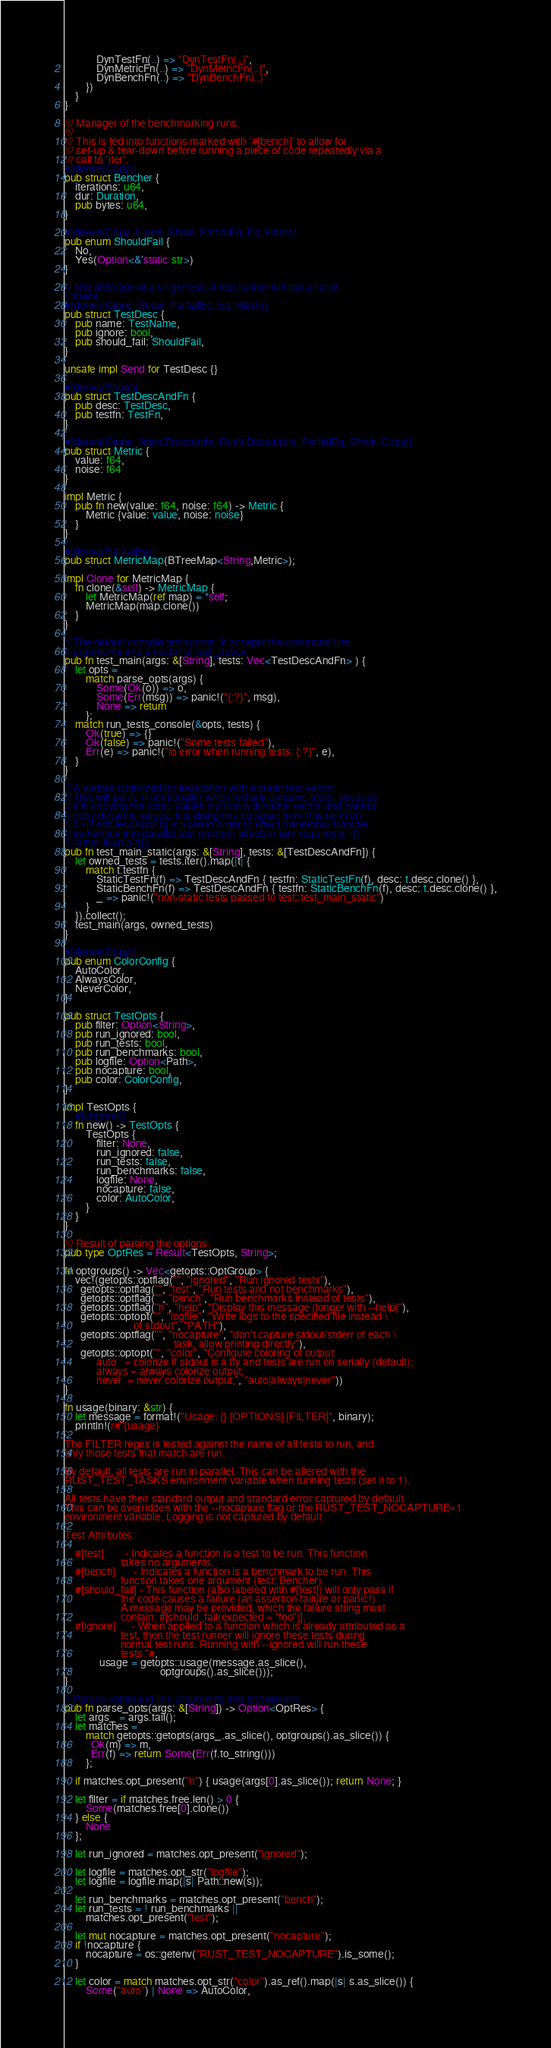Convert code to text. <code><loc_0><loc_0><loc_500><loc_500><_Rust_>            DynTestFn(..) => "DynTestFn(..)",
            DynMetricFn(..) => "DynMetricFn(..)",
            DynBenchFn(..) => "DynBenchFn(..)"
        })
    }
}

/// Manager of the benchmarking runs.
///
/// This is fed into functions marked with `#[bench]` to allow for
/// set-up & tear-down before running a piece of code repeatedly via a
/// call to `iter`.
#[derive(Copy)]
pub struct Bencher {
    iterations: u64,
    dur: Duration,
    pub bytes: u64,
}

#[derive(Copy, Clone, Show, PartialEq, Eq, Hash)]
pub enum ShouldFail {
    No,
    Yes(Option<&'static str>)
}

// The definition of a single test. A test runner will run a list of
// these.
#[derive(Clone, Show, PartialEq, Eq, Hash)]
pub struct TestDesc {
    pub name: TestName,
    pub ignore: bool,
    pub should_fail: ShouldFail,
}

unsafe impl Send for TestDesc {}

#[derive(Show)]
pub struct TestDescAndFn {
    pub desc: TestDesc,
    pub testfn: TestFn,
}

#[derive(Clone, RustcEncodable, RustcDecodable, PartialEq, Show, Copy)]
pub struct Metric {
    value: f64,
    noise: f64
}

impl Metric {
    pub fn new(value: f64, noise: f64) -> Metric {
        Metric {value: value, noise: noise}
    }
}

#[derive(PartialEq)]
pub struct MetricMap(BTreeMap<String,Metric>);

impl Clone for MetricMap {
    fn clone(&self) -> MetricMap {
        let MetricMap(ref map) = *self;
        MetricMap(map.clone())
    }
}

// The default console test runner. It accepts the command line
// arguments and a vector of test_descs.
pub fn test_main(args: &[String], tests: Vec<TestDescAndFn> ) {
    let opts =
        match parse_opts(args) {
            Some(Ok(o)) => o,
            Some(Err(msg)) => panic!("{:?}", msg),
            None => return
        };
    match run_tests_console(&opts, tests) {
        Ok(true) => {}
        Ok(false) => panic!("Some tests failed"),
        Err(e) => panic!("io error when running tests: {:?}", e),
    }
}

// A variant optimized for invocation with a static test vector.
// This will panic (intentionally) when fed any dynamic tests, because
// it is copying the static values out into a dynamic vector and cannot
// copy dynamic values. It is doing this because from this point on
// a ~[TestDescAndFn] is used in order to effect ownership-transfer
// semantics into parallel test runners, which in turn requires a ~[]
// rather than a &[].
pub fn test_main_static(args: &[String], tests: &[TestDescAndFn]) {
    let owned_tests = tests.iter().map(|t| {
        match t.testfn {
            StaticTestFn(f) => TestDescAndFn { testfn: StaticTestFn(f), desc: t.desc.clone() },
            StaticBenchFn(f) => TestDescAndFn { testfn: StaticBenchFn(f), desc: t.desc.clone() },
            _ => panic!("non-static tests passed to test::test_main_static")
        }
    }).collect();
    test_main(args, owned_tests)
}

#[derive(Copy)]
pub enum ColorConfig {
    AutoColor,
    AlwaysColor,
    NeverColor,
}

pub struct TestOpts {
    pub filter: Option<String>,
    pub run_ignored: bool,
    pub run_tests: bool,
    pub run_benchmarks: bool,
    pub logfile: Option<Path>,
    pub nocapture: bool,
    pub color: ColorConfig,
}

impl TestOpts {
    #[cfg(test)]
    fn new() -> TestOpts {
        TestOpts {
            filter: None,
            run_ignored: false,
            run_tests: false,
            run_benchmarks: false,
            logfile: None,
            nocapture: false,
            color: AutoColor,
        }
    }
}

/// Result of parsing the options.
pub type OptRes = Result<TestOpts, String>;

fn optgroups() -> Vec<getopts::OptGroup> {
    vec!(getopts::optflag("", "ignored", "Run ignored tests"),
      getopts::optflag("", "test", "Run tests and not benchmarks"),
      getopts::optflag("", "bench", "Run benchmarks instead of tests"),
      getopts::optflag("h", "help", "Display this message (longer with --help)"),
      getopts::optopt("", "logfile", "Write logs to the specified file instead \
                          of stdout", "PATH"),
      getopts::optflag("", "nocapture", "don't capture stdout/stderr of each \
                                         task, allow printing directly"),
      getopts::optopt("", "color", "Configure coloring of output:
            auto   = colorize if stdout is a tty and tests are run on serially (default);
            always = always colorize output;
            never  = never colorize output;", "auto|always|never"))
}

fn usage(binary: &str) {
    let message = format!("Usage: {} [OPTIONS] [FILTER]", binary);
    println!(r#"{usage}

The FILTER regex is tested against the name of all tests to run, and
only those tests that match are run.

By default, all tests are run in parallel. This can be altered with the
RUST_TEST_TASKS environment variable when running tests (set it to 1).

All tests have their standard output and standard error captured by default.
This can be overridden with the --nocapture flag or the RUST_TEST_NOCAPTURE=1
environment variable. Logging is not captured by default.

Test Attributes:

    #[test]        - Indicates a function is a test to be run. This function
                     takes no arguments.
    #[bench]       - Indicates a function is a benchmark to be run. This
                     function takes one argument (test::Bencher).
    #[should_fail] - This function (also labeled with #[test]) will only pass if
                     the code causes a failure (an assertion failure or panic!)
                     A message may be provided, which the failure string must
                     contain: #[should_fail(expected = "foo")].
    #[ignore]      - When applied to a function which is already attributed as a
                     test, then the test runner will ignore these tests during
                     normal test runs. Running with --ignored will run these
                     tests."#,
             usage = getopts::usage(message.as_slice(),
                                    optgroups().as_slice()));
}

// Parses command line arguments into test options
pub fn parse_opts(args: &[String]) -> Option<OptRes> {
    let args_ = args.tail();
    let matches =
        match getopts::getopts(args_.as_slice(), optgroups().as_slice()) {
          Ok(m) => m,
          Err(f) => return Some(Err(f.to_string()))
        };

    if matches.opt_present("h") { usage(args[0].as_slice()); return None; }

    let filter = if matches.free.len() > 0 {
        Some(matches.free[0].clone())
    } else {
        None
    };

    let run_ignored = matches.opt_present("ignored");

    let logfile = matches.opt_str("logfile");
    let logfile = logfile.map(|s| Path::new(s));

    let run_benchmarks = matches.opt_present("bench");
    let run_tests = ! run_benchmarks ||
        matches.opt_present("test");

    let mut nocapture = matches.opt_present("nocapture");
    if !nocapture {
        nocapture = os::getenv("RUST_TEST_NOCAPTURE").is_some();
    }

    let color = match matches.opt_str("color").as_ref().map(|s| s.as_slice()) {
        Some("auto") | None => AutoColor,</code> 